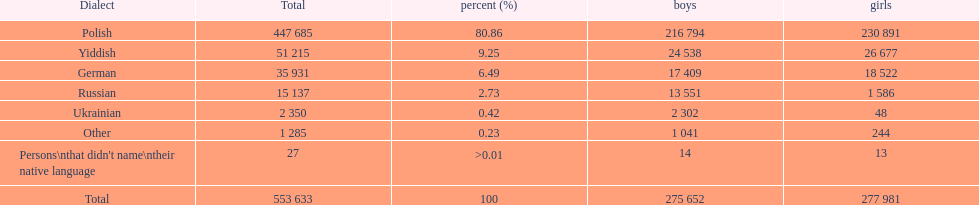Which is the least spoken language? Ukrainian. Can you parse all the data within this table? {'header': ['Dialect', 'Total', 'percent (%)', 'boys', 'girls'], 'rows': [['Polish', '447 685', '80.86', '216 794', '230 891'], ['Yiddish', '51 215', '9.25', '24 538', '26 677'], ['German', '35 931', '6.49', '17 409', '18 522'], ['Russian', '15 137', '2.73', '13 551', '1 586'], ['Ukrainian', '2 350', '0.42', '2 302', '48'], ['Other', '1 285', '0.23', '1 041', '244'], ["Persons\\nthat didn't name\\ntheir native language", '27', '>0.01', '14', '13'], ['Total', '553 633', '100', '275 652', '277 981']]} 